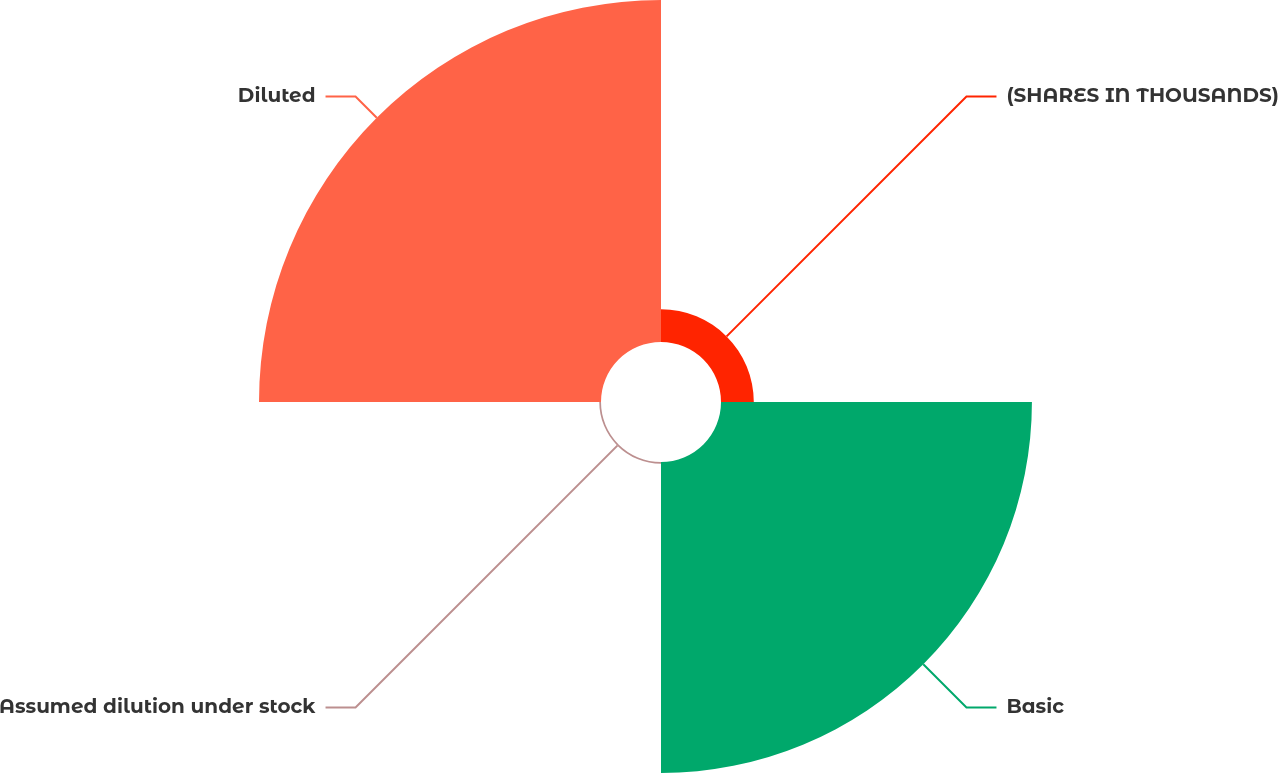Convert chart to OTSL. <chart><loc_0><loc_0><loc_500><loc_500><pie_chart><fcel>(SHARES IN THOUSANDS)<fcel>Basic<fcel>Assumed dilution under stock<fcel>Diluted<nl><fcel>4.77%<fcel>45.23%<fcel>0.25%<fcel>49.75%<nl></chart> 